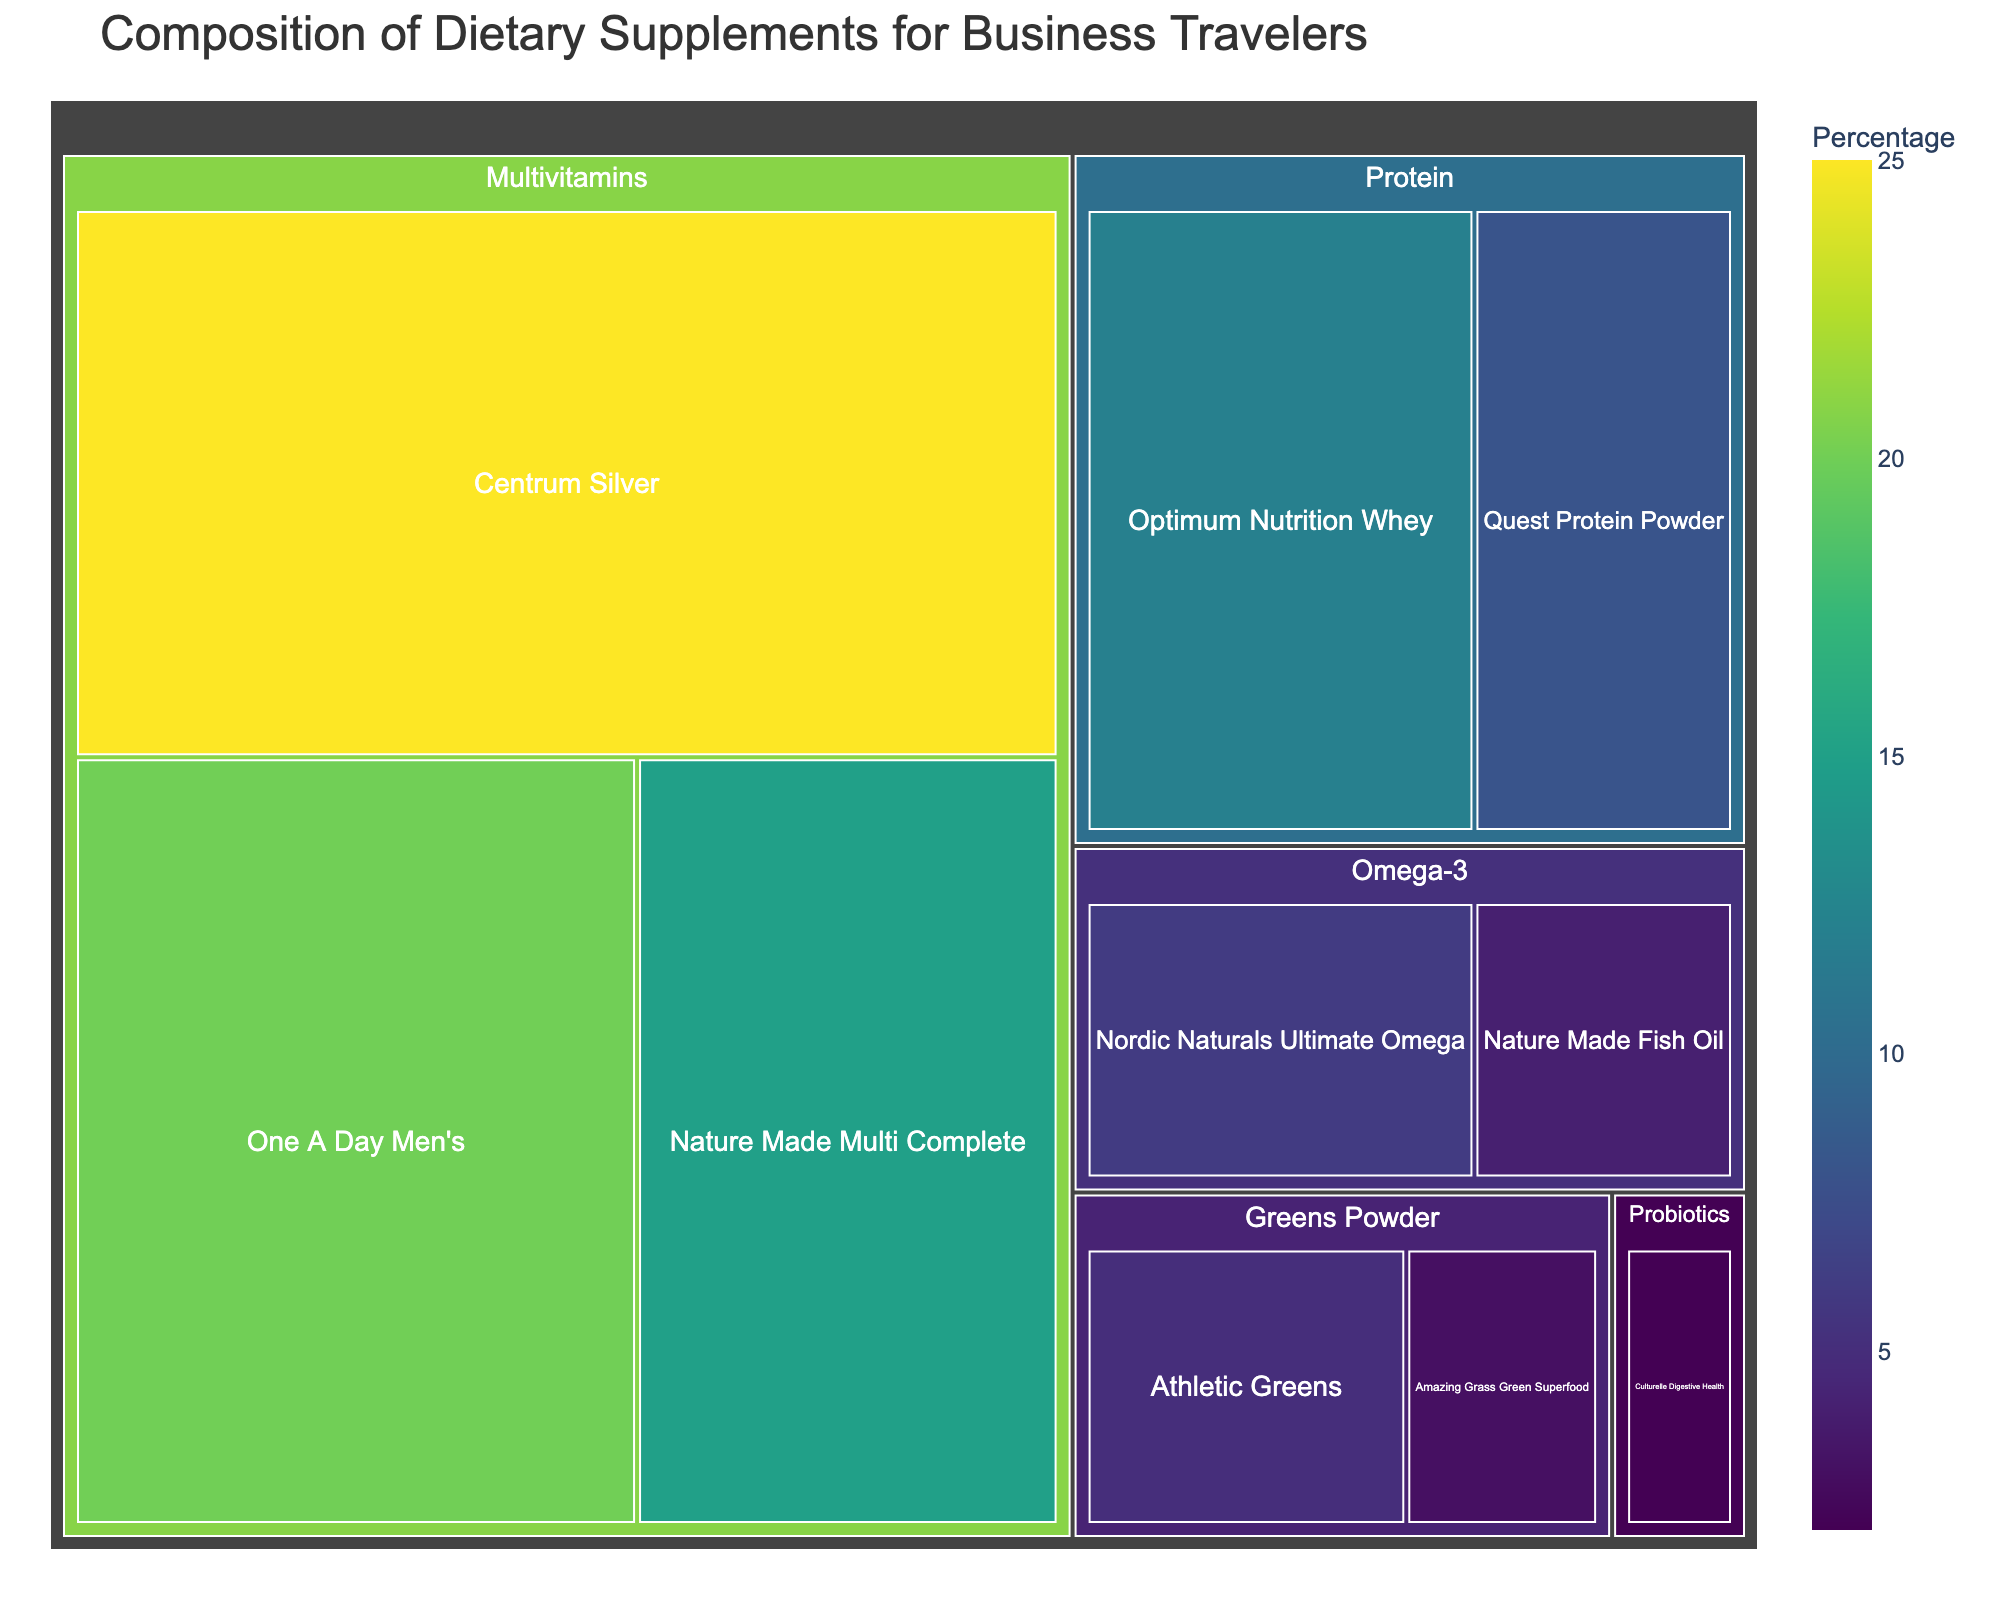What's the title of the figure? The title is usually at the top of the figure and provides an overview of what the figure represents.
Answer: Composition of Dietary Supplements for Business Travelers How many categories of dietary supplements are represented? Look for the distinct main tiles or segments that represent the broad classification of supplements.
Answer: 5 Which dietary supplement has the highest percentage? Identify the supplement with the largest tile or segment within the figure, which indicates the highest value.
Answer: Centrum Silver What is the combined percentage of all Protein supplements? Add the percentages of all supplements under the Protein category: Optimum Nutrition Whey (12%) + Quest Protein Powder (8%).
Answer: 20% Which category has the smallest total percentage? Sum the percentages of each category and compare them to identify the smallest total. Probiotics only has one supplement with 2%.
Answer: Probiotics How does the percentage of Centrum Silver compare to One A Day Men's? Directly compare the percentages given for Centrum Silver (25%) and One A Day Men's (20%).
Answer: Centrum Silver is 5% higher What is the combined percentage of all Omega-3 and Greens Powder supplements? Add the percentages of supplements under Omega-3: Nordic Naturals Ultimate Omega (6%) + Nature Made Fish Oil (4%), and Greens Powder: Athletic Greens (5%) + Amazing Grass Green Superfood (3%). Then, sum the totals of these two categories (6% + 4% + 5% + 3%).
Answer: 18% Which category has supplements listed with the smallest individual percentages? Identify the category with the lowest individual percentage. Probiotics has Culturelle Digestive Health with 2%.
Answer: Probiotics Are there more supplements under Multivitamins or Protein? Count the number of supplements listed under each category. Multivitamins have 3 (Centrum Silver, One A Day Men's, Nature Made Multi Complete) and Protein has 2 (Optimum Nutrition Whey, Quest Protein Powder).
Answer: Multivitamins Which category has the most varied supplement types visually? Determine which category has the most distinct supplements with differing percentages, considering the visual differences in the sizes of the tiles. Multivitamins have the most varied as they have three supplements with different percentages (25%, 20%, 15%).
Answer: Multivitamins 